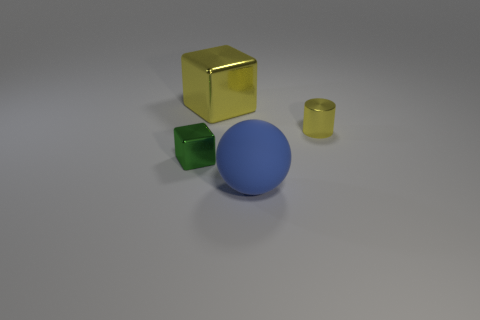There is a cylinder; is its color the same as the large thing to the left of the big blue ball?
Offer a terse response. Yes. How many large shiny objects have the same shape as the matte thing?
Keep it short and to the point. 0. There is a tiny thing on the left side of the cylinder; what material is it?
Offer a terse response. Metal. Do the shiny thing that is to the right of the sphere and the large yellow metallic object have the same shape?
Ensure brevity in your answer.  No. Is there a green shiny thing of the same size as the yellow cylinder?
Provide a succinct answer. Yes. There is a small green object; is its shape the same as the small shiny object right of the large yellow block?
Give a very brief answer. No. The large object that is the same color as the cylinder is what shape?
Your answer should be compact. Cube. Are there fewer big shiny cubes that are on the right side of the small cylinder than tiny blocks?
Offer a terse response. Yes. Is the shape of the large metal object the same as the tiny yellow metallic thing?
Your answer should be compact. No. There is a green block that is made of the same material as the yellow cube; what is its size?
Ensure brevity in your answer.  Small. 